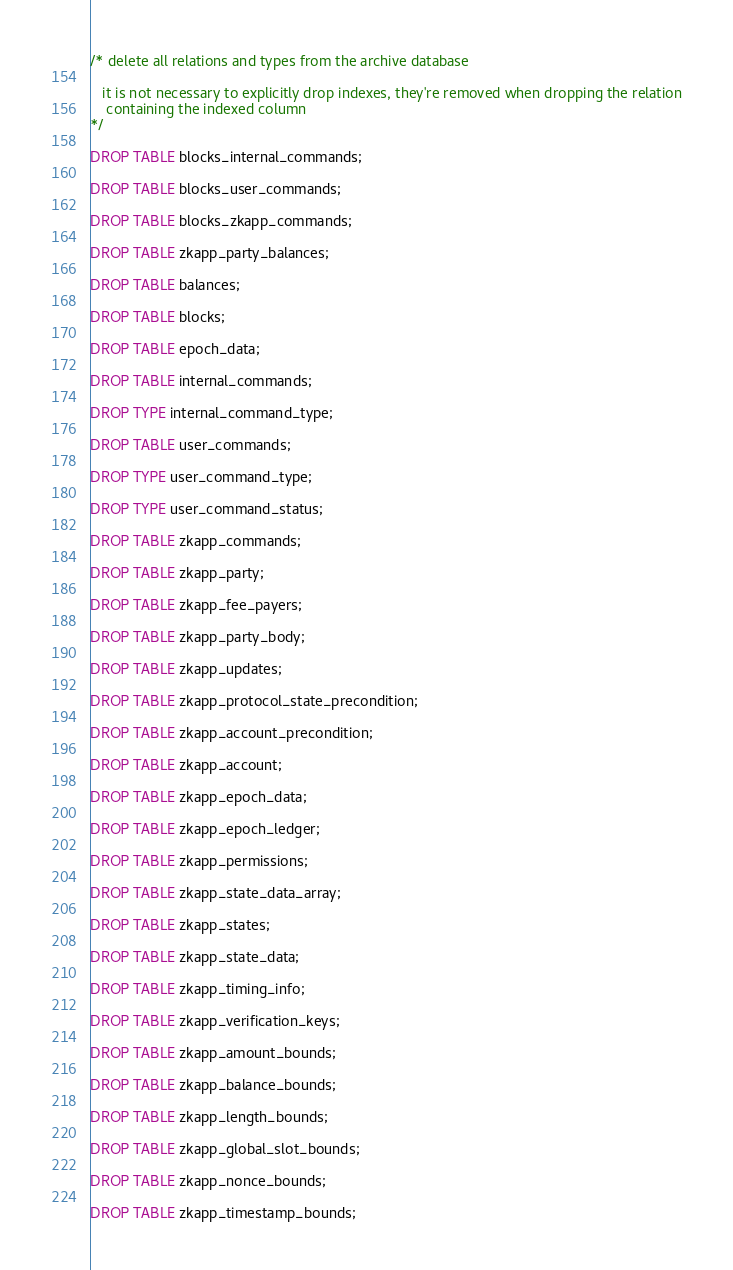<code> <loc_0><loc_0><loc_500><loc_500><_SQL_>/* delete all relations and types from the archive database

   it is not necessary to explicitly drop indexes, they're removed when dropping the relation
    containing the indexed column
*/

DROP TABLE blocks_internal_commands;

DROP TABLE blocks_user_commands;

DROP TABLE blocks_zkapp_commands;

DROP TABLE zkapp_party_balances;

DROP TABLE balances;

DROP TABLE blocks;

DROP TABLE epoch_data;

DROP TABLE internal_commands;

DROP TYPE internal_command_type;

DROP TABLE user_commands;

DROP TYPE user_command_type;

DROP TYPE user_command_status;

DROP TABLE zkapp_commands;

DROP TABLE zkapp_party;

DROP TABLE zkapp_fee_payers;

DROP TABLE zkapp_party_body;

DROP TABLE zkapp_updates;

DROP TABLE zkapp_protocol_state_precondition;

DROP TABLE zkapp_account_precondition;

DROP TABLE zkapp_account;

DROP TABLE zkapp_epoch_data;

DROP TABLE zkapp_epoch_ledger;

DROP TABLE zkapp_permissions;

DROP TABLE zkapp_state_data_array;

DROP TABLE zkapp_states;

DROP TABLE zkapp_state_data;

DROP TABLE zkapp_timing_info;

DROP TABLE zkapp_verification_keys;

DROP TABLE zkapp_amount_bounds;

DROP TABLE zkapp_balance_bounds;

DROP TABLE zkapp_length_bounds;

DROP TABLE zkapp_global_slot_bounds;

DROP TABLE zkapp_nonce_bounds;

DROP TABLE zkapp_timestamp_bounds;
</code> 